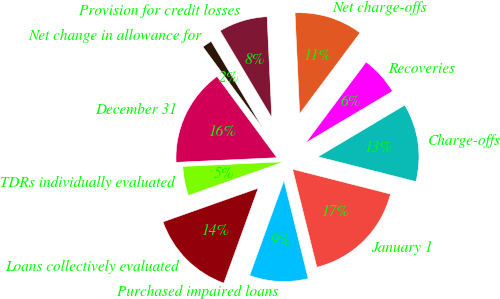<chart> <loc_0><loc_0><loc_500><loc_500><pie_chart><fcel>January 1<fcel>Charge-offs<fcel>Recoveries<fcel>Net charge-offs<fcel>Provision for credit losses<fcel>Net change in allowance for<fcel>December 31<fcel>TDRs individually evaluated<fcel>Loans collectively evaluated<fcel>Purchased impaired loans<nl><fcel>17.19%<fcel>12.5%<fcel>6.25%<fcel>10.94%<fcel>7.81%<fcel>1.56%<fcel>15.62%<fcel>4.69%<fcel>14.06%<fcel>9.38%<nl></chart> 